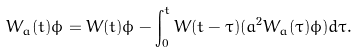<formula> <loc_0><loc_0><loc_500><loc_500>W _ { a } ( t ) \phi = W ( t ) \phi - \int _ { 0 } ^ { t } W ( t - \tau ) ( a ^ { 2 } W _ { a } ( \tau ) \phi ) d \tau .</formula> 